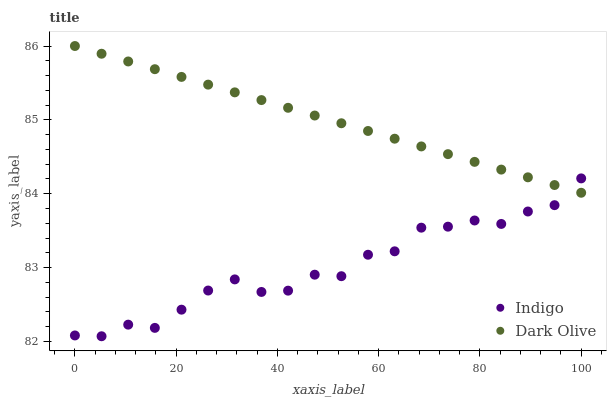Does Indigo have the minimum area under the curve?
Answer yes or no. Yes. Does Dark Olive have the maximum area under the curve?
Answer yes or no. Yes. Does Indigo have the maximum area under the curve?
Answer yes or no. No. Is Dark Olive the smoothest?
Answer yes or no. Yes. Is Indigo the roughest?
Answer yes or no. Yes. Is Indigo the smoothest?
Answer yes or no. No. Does Indigo have the lowest value?
Answer yes or no. Yes. Does Dark Olive have the highest value?
Answer yes or no. Yes. Does Indigo have the highest value?
Answer yes or no. No. Does Indigo intersect Dark Olive?
Answer yes or no. Yes. Is Indigo less than Dark Olive?
Answer yes or no. No. Is Indigo greater than Dark Olive?
Answer yes or no. No. 